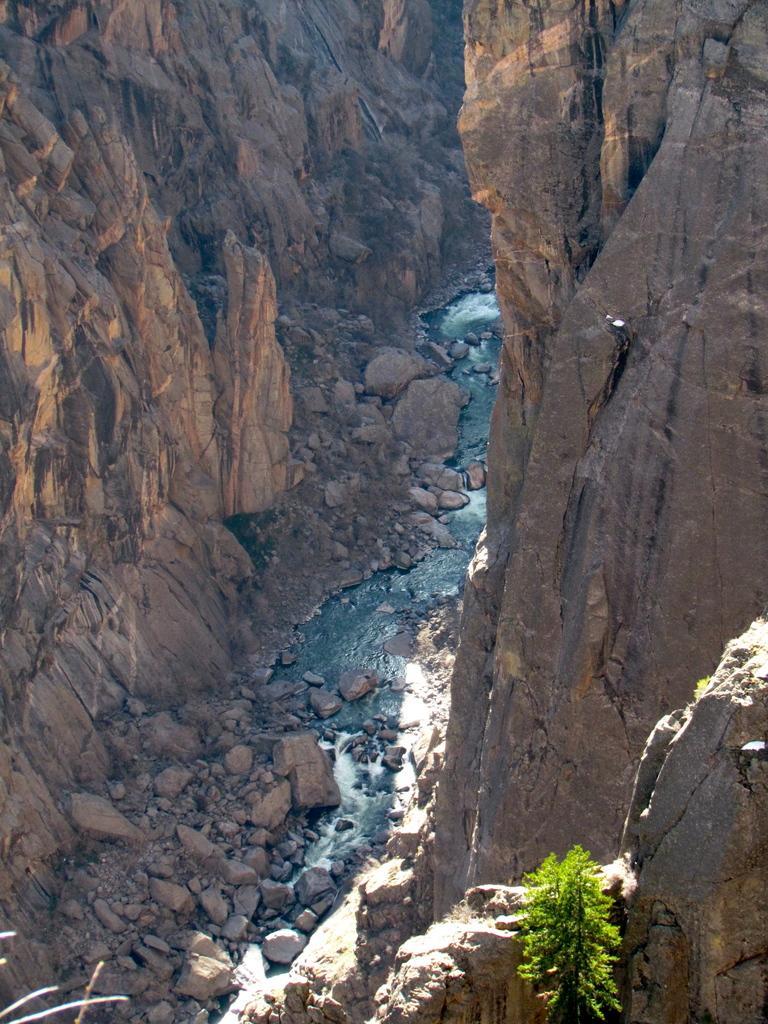In one or two sentences, can you explain what this image depicts? In this image we can see a water stream and mountains. There is a plant at the bottom of the image. 